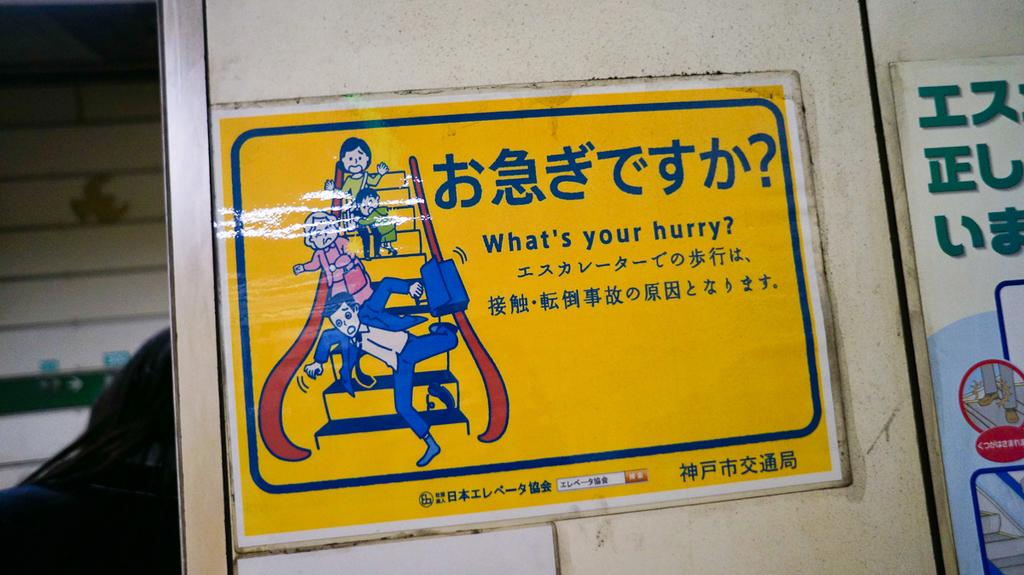Provide a one-sentence caption for the provided image. the question of what's your hurry is written on a yellow sign. 